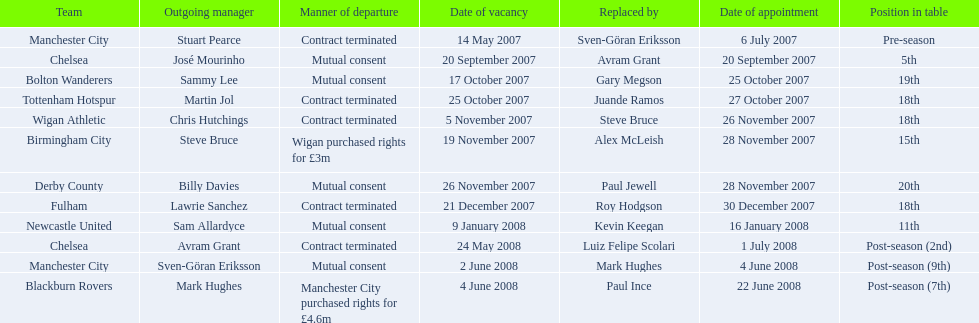Who became the manchester city manager following stuart pearce's departure in 2007? Sven-Göran Eriksson. Help me parse the entirety of this table. {'header': ['Team', 'Outgoing manager', 'Manner of departure', 'Date of vacancy', 'Replaced by', 'Date of appointment', 'Position in table'], 'rows': [['Manchester City', 'Stuart Pearce', 'Contract terminated', '14 May 2007', 'Sven-Göran Eriksson', '6 July 2007', 'Pre-season'], ['Chelsea', 'José Mourinho', 'Mutual consent', '20 September 2007', 'Avram Grant', '20 September 2007', '5th'], ['Bolton Wanderers', 'Sammy Lee', 'Mutual consent', '17 October 2007', 'Gary Megson', '25 October 2007', '19th'], ['Tottenham Hotspur', 'Martin Jol', 'Contract terminated', '25 October 2007', 'Juande Ramos', '27 October 2007', '18th'], ['Wigan Athletic', 'Chris Hutchings', 'Contract terminated', '5 November 2007', 'Steve Bruce', '26 November 2007', '18th'], ['Birmingham City', 'Steve Bruce', 'Wigan purchased rights for £3m', '19 November 2007', 'Alex McLeish', '28 November 2007', '15th'], ['Derby County', 'Billy Davies', 'Mutual consent', '26 November 2007', 'Paul Jewell', '28 November 2007', '20th'], ['Fulham', 'Lawrie Sanchez', 'Contract terminated', '21 December 2007', 'Roy Hodgson', '30 December 2007', '18th'], ['Newcastle United', 'Sam Allardyce', 'Mutual consent', '9 January 2008', 'Kevin Keegan', '16 January 2008', '11th'], ['Chelsea', 'Avram Grant', 'Contract terminated', '24 May 2008', 'Luiz Felipe Scolari', '1 July 2008', 'Post-season (2nd)'], ['Manchester City', 'Sven-Göran Eriksson', 'Mutual consent', '2 June 2008', 'Mark Hughes', '4 June 2008', 'Post-season (9th)'], ['Blackburn Rovers', 'Mark Hughes', 'Manchester City purchased rights for £4.6m', '4 June 2008', 'Paul Ince', '22 June 2008', 'Post-season (7th)']]} 